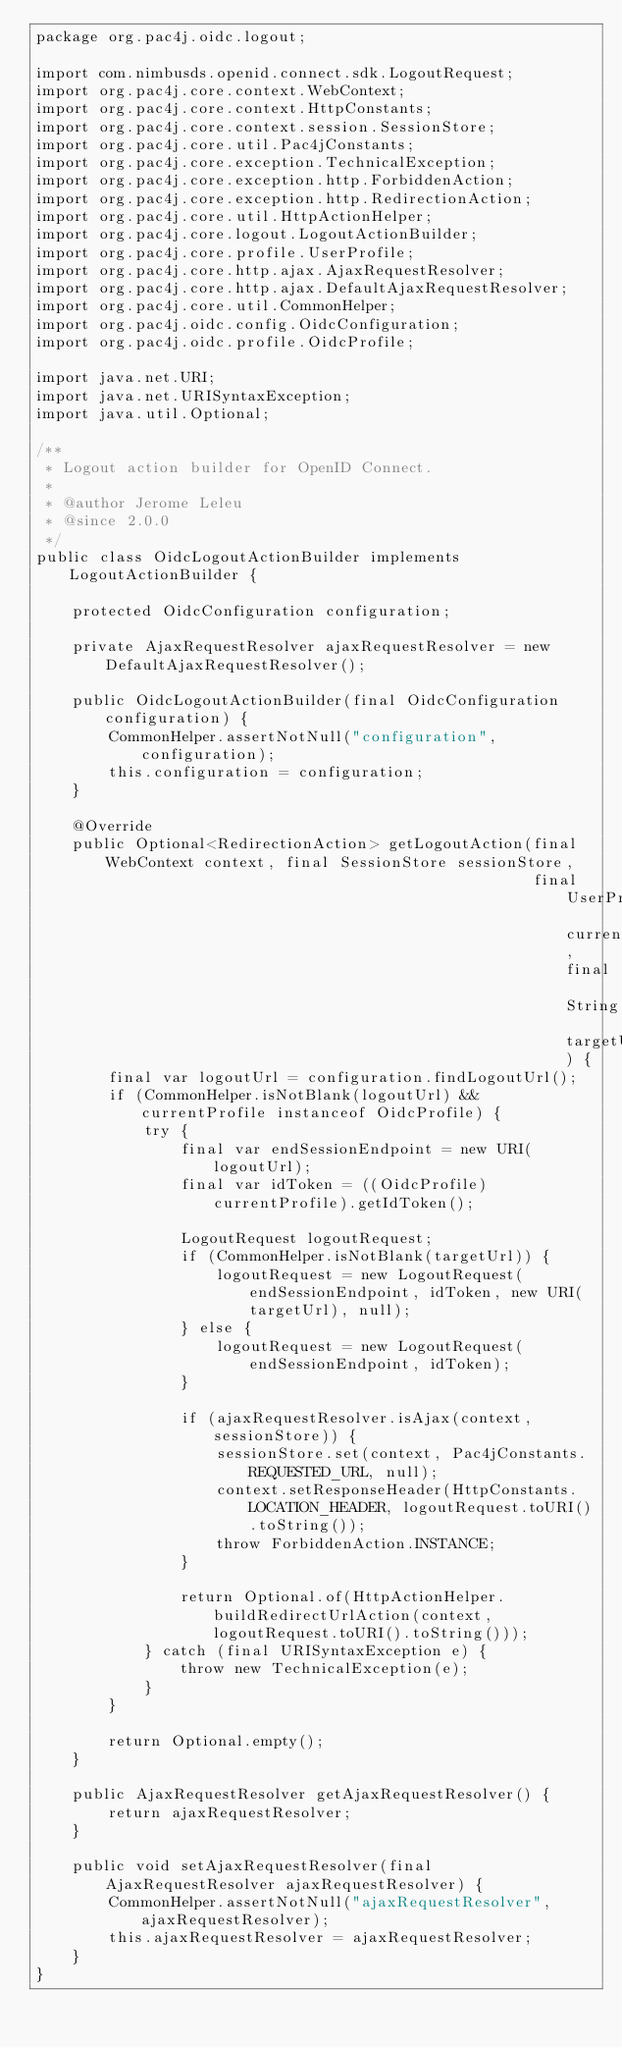<code> <loc_0><loc_0><loc_500><loc_500><_Java_>package org.pac4j.oidc.logout;

import com.nimbusds.openid.connect.sdk.LogoutRequest;
import org.pac4j.core.context.WebContext;
import org.pac4j.core.context.HttpConstants;
import org.pac4j.core.context.session.SessionStore;
import org.pac4j.core.util.Pac4jConstants;
import org.pac4j.core.exception.TechnicalException;
import org.pac4j.core.exception.http.ForbiddenAction;
import org.pac4j.core.exception.http.RedirectionAction;
import org.pac4j.core.util.HttpActionHelper;
import org.pac4j.core.logout.LogoutActionBuilder;
import org.pac4j.core.profile.UserProfile;
import org.pac4j.core.http.ajax.AjaxRequestResolver;
import org.pac4j.core.http.ajax.DefaultAjaxRequestResolver;
import org.pac4j.core.util.CommonHelper;
import org.pac4j.oidc.config.OidcConfiguration;
import org.pac4j.oidc.profile.OidcProfile;

import java.net.URI;
import java.net.URISyntaxException;
import java.util.Optional;

/**
 * Logout action builder for OpenID Connect.
 *
 * @author Jerome Leleu
 * @since 2.0.0
 */
public class OidcLogoutActionBuilder implements LogoutActionBuilder {

    protected OidcConfiguration configuration;

    private AjaxRequestResolver ajaxRequestResolver = new DefaultAjaxRequestResolver();

    public OidcLogoutActionBuilder(final OidcConfiguration configuration) {
        CommonHelper.assertNotNull("configuration", configuration);
        this.configuration = configuration;
    }

    @Override
    public Optional<RedirectionAction> getLogoutAction(final WebContext context, final SessionStore sessionStore,
                                                       final UserProfile currentProfile, final String targetUrl) {
        final var logoutUrl = configuration.findLogoutUrl();
        if (CommonHelper.isNotBlank(logoutUrl) && currentProfile instanceof OidcProfile) {
            try {
                final var endSessionEndpoint = new URI(logoutUrl);
                final var idToken = ((OidcProfile) currentProfile).getIdToken();

                LogoutRequest logoutRequest;
                if (CommonHelper.isNotBlank(targetUrl)) {
                    logoutRequest = new LogoutRequest(endSessionEndpoint, idToken, new URI(targetUrl), null);
                } else {
                    logoutRequest = new LogoutRequest(endSessionEndpoint, idToken);
                }

                if (ajaxRequestResolver.isAjax(context, sessionStore)) {
                    sessionStore.set(context, Pac4jConstants.REQUESTED_URL, null);
                    context.setResponseHeader(HttpConstants.LOCATION_HEADER, logoutRequest.toURI().toString());
                    throw ForbiddenAction.INSTANCE;
                }

                return Optional.of(HttpActionHelper.buildRedirectUrlAction(context, logoutRequest.toURI().toString()));
            } catch (final URISyntaxException e) {
                throw new TechnicalException(e);
            }
        }

        return Optional.empty();
    }

    public AjaxRequestResolver getAjaxRequestResolver() {
        return ajaxRequestResolver;
    }

    public void setAjaxRequestResolver(final AjaxRequestResolver ajaxRequestResolver) {
        CommonHelper.assertNotNull("ajaxRequestResolver", ajaxRequestResolver);
        this.ajaxRequestResolver = ajaxRequestResolver;
    }
}
</code> 